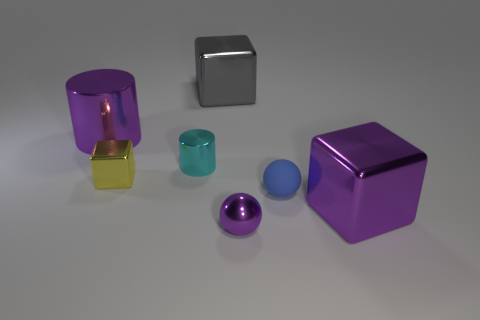Add 2 gray cylinders. How many objects exist? 9 Subtract all blocks. How many objects are left? 4 Subtract 0 green cylinders. How many objects are left? 7 Subtract all purple cylinders. Subtract all large purple cubes. How many objects are left? 5 Add 5 large purple cylinders. How many large purple cylinders are left? 6 Add 2 small brown objects. How many small brown objects exist? 2 